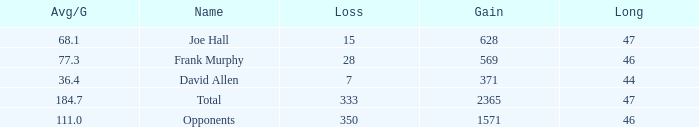Which Avg/G has a Name of david allen, and a Gain larger than 371? None. 